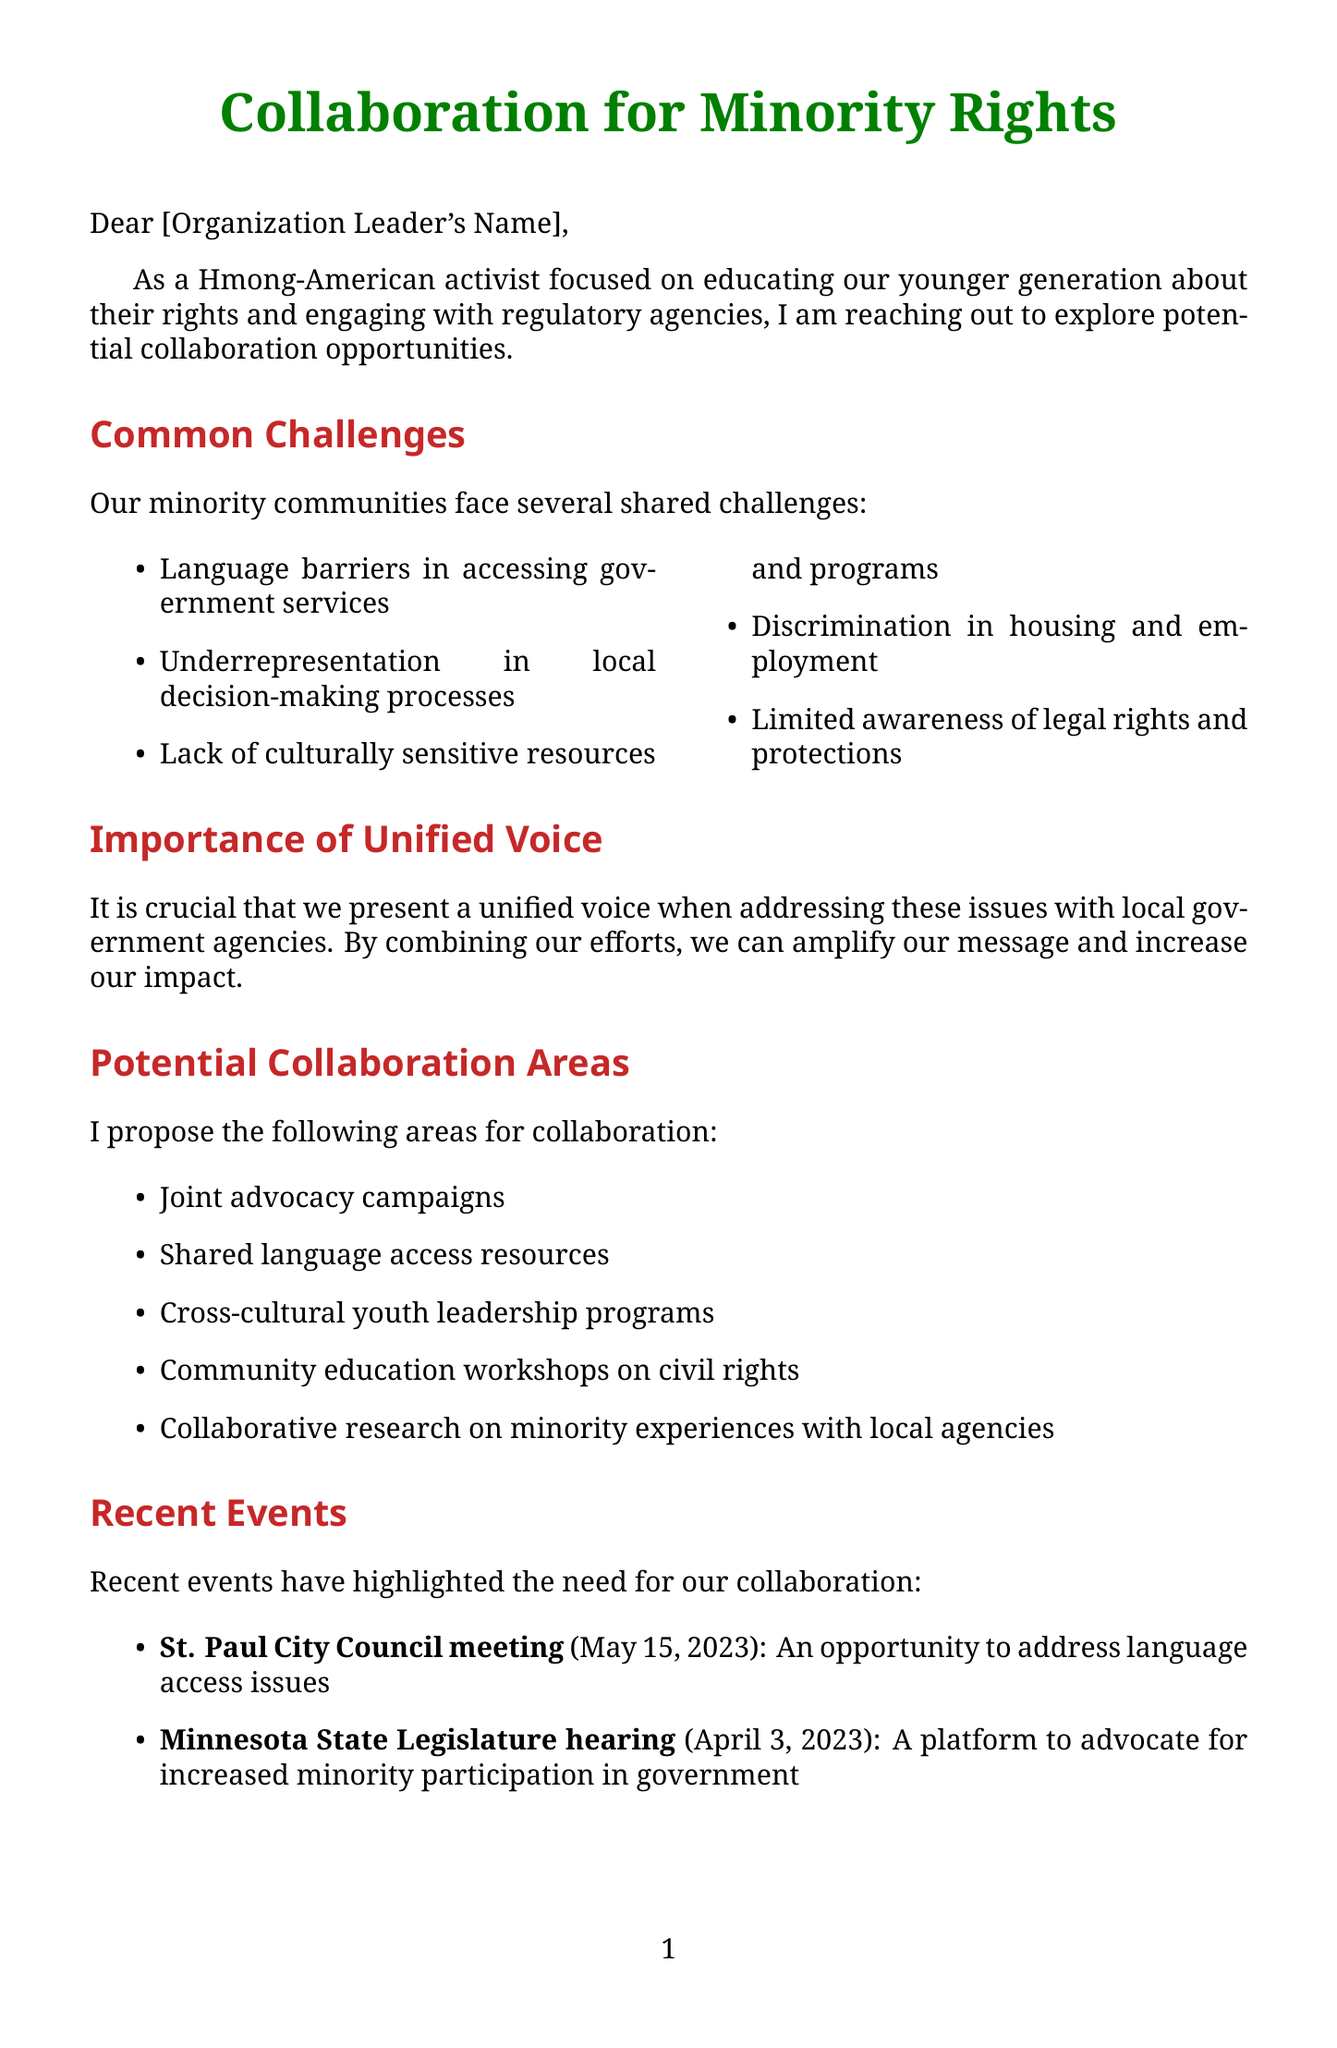What is the name of the letter's author? The author is identified as a Hmong-American Rights Activist in the closing segment of the letter.
Answer: Hmong-American Rights Activist What is one common challenge faced by minority groups mentioned in the document? The letter lists multiple challenges, one being "Language barriers in accessing government services."
Answer: Language barriers in accessing government services Which organization focuses on civil and human rights advocacy for Asian Americans? The document provides a list of relevant organizations, one being "Asian Americans Advancing Justice."
Answer: Asian Americans Advancing Justice What is the date of the St. Paul City Council meeting mentioned? The date is included in the recent events section, specifically "May 15, 2023."
Answer: May 15, 2023 What is one proposed next step for collaboration? The next steps listed include multiple options, one being "Schedule an initial meeting to discuss shared goals."
Answer: Schedule an initial meeting to discuss shared goals What is the significance of the Minnesota State Legislature hearing? The significance of the event is stated as "A platform to advocate for increased minority participation in government."
Answer: A platform to advocate for increased minority participation in government What type of programs are suggested for cross-cultural youth leadership? The letter specifically mentions "Cross-cultural youth leadership programs."
Answer: Cross-cultural youth leadership programs What is emphasized as crucial for presenting issues to local government agencies? The document emphasizes the importance of presenting "a unified voice" when addressing issues.
Answer: a unified voice 